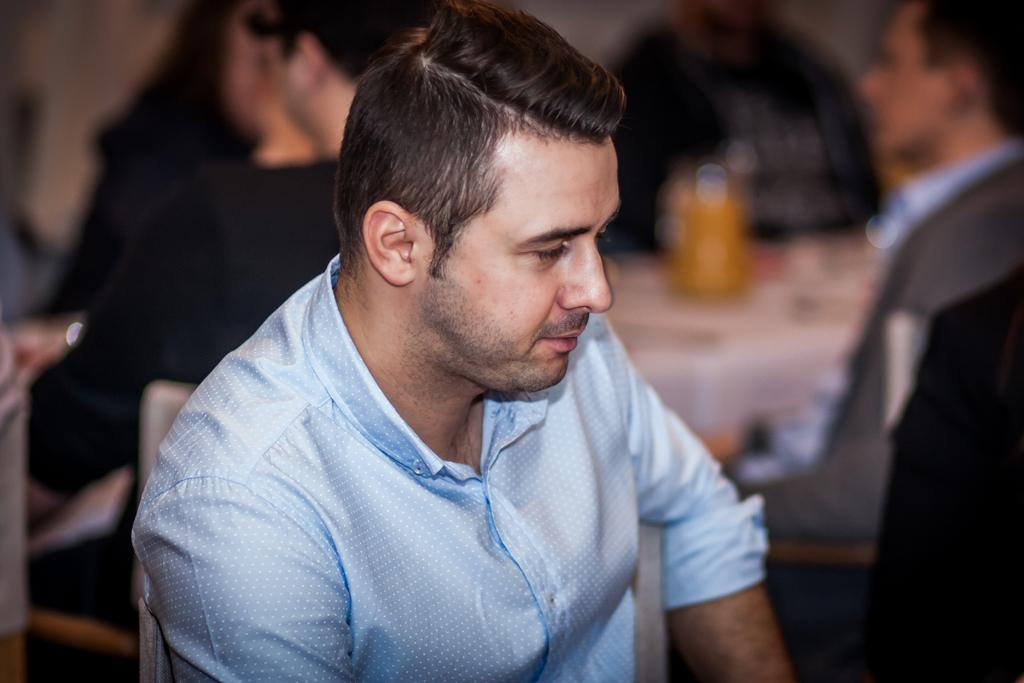What is the man in the image doing? The man is sitting on a chair in the image. Can you describe the setting in the image? There are other people sitting in the background of the image, and there is a table visible. How many toes can be seen on the pigs in the image? There are no pigs present in the image, so it is not possible to determine the number of toes on any pigs. 